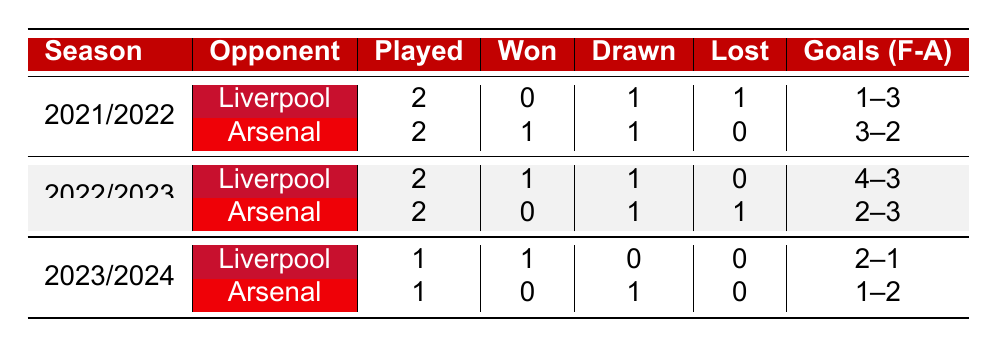What was Manchester United's performance against Liverpool in the 2021/2022 season? In the 2021/2022 season, Manchester United played 2 matches against Liverpool, won 0, drew 1, and lost 1. They scored 1 goal and conceded 3.
Answer: 0 wins, 1 draw, 1 loss How many matches did Manchester United win against Arsenal in the 2022/2023 season? In the 2022/2023 season, Manchester United played 2 matches against Arsenal and won 0 of them.
Answer: 0 wins Did Manchester United score more goals against Liverpool than Arsenal in the 2023/2024 season? In the 2023/2024 season, Manchester United scored 2 goals against Liverpool and 1 goal against Arsenal. Since 2 is greater than 1, they scored more against Liverpool.
Answer: Yes What is the total number of matches Manchester United played against Liverpool and Arsenal in the 2022/2023 season? In the 2022/2023 season, Manchester United played 2 matches against Liverpool and 2 matches against Arsenal, leading to a total of 4 matches.
Answer: 4 matches How many goals did Manchester United concede against Arsenal across the three seasons? Across the three seasons, Manchester United conceded goals as follows against Arsenal: 2 in 2021/2022, 3 in 2022/2023, and 2 in 2023/2024. Adding these results (2 + 3 + 2), Manchester United conceded a total of 7 goals against Arsenal.
Answer: 7 goals Which opponent did Manchester United win against in the 2021/2022 season? In the 2021/2022 season, Manchester United only won against Arsenal, as they lost and drew against Liverpool.
Answer: Arsenal Was there a season where Manchester United performed better against Liverpool than Arsenal based on wins? In 2021/2022 Manchester United won 1 match against Arsenal and 0 against Liverpool, making them perform better against Arsenal in that season.
Answer: Yes In how many matches did Manchester United have a draw against Liverpool from 2021/2022 to 2023/2024? In the corresponding seasons, Manchester United had 1 draw against Liverpool in the 2021/2022 season and 1 draw in the 2022/2023 season, totaling 2 drawn matches against Liverpool.
Answer: 2 draws 